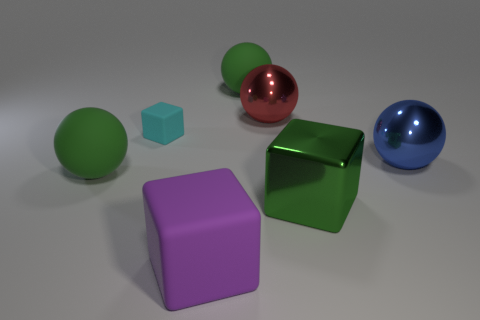Is there any other thing that is the same size as the cyan matte thing?
Keep it short and to the point. No. Is there any other thing that is the same shape as the small object?
Ensure brevity in your answer.  Yes. There is another matte thing that is the same shape as the big purple object; what color is it?
Keep it short and to the point. Cyan. Do the cyan rubber thing and the blue object have the same size?
Keep it short and to the point. No. How many other objects are the same size as the purple matte thing?
Give a very brief answer. 5. How many things are either large balls that are in front of the large red object or cubes that are right of the big purple object?
Offer a terse response. 3. There is a purple matte thing that is the same size as the blue sphere; what shape is it?
Your answer should be compact. Cube. There is a block that is the same material as the tiny cyan object; what is its size?
Give a very brief answer. Large. Is the shape of the small rubber object the same as the purple matte object?
Your answer should be compact. Yes. The other block that is the same size as the green shiny block is what color?
Your answer should be very brief. Purple. 